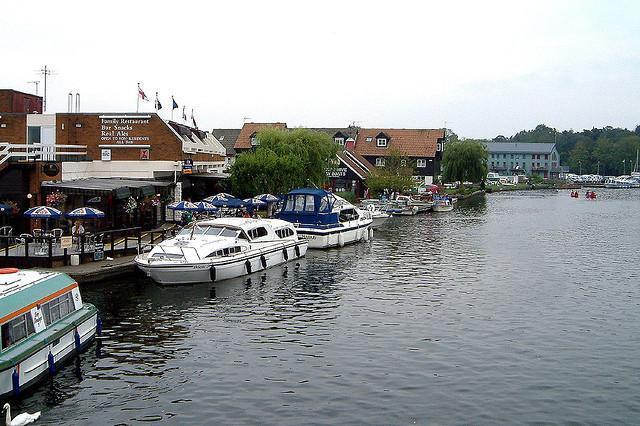How many boats are in the foreground?
Give a very brief answer. 3. How many boats are in the photo?
Give a very brief answer. 3. 